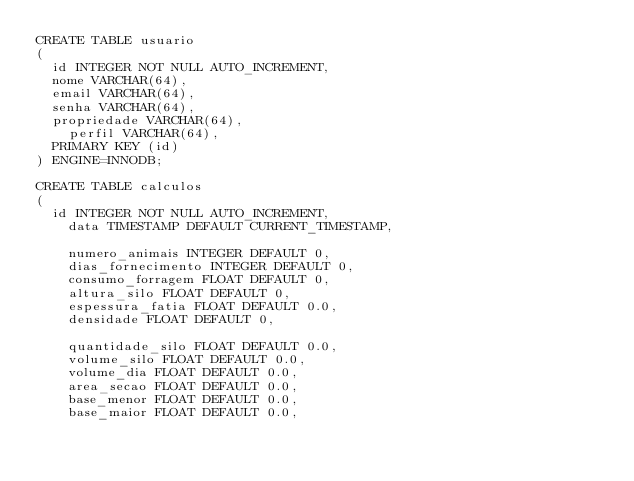Convert code to text. <code><loc_0><loc_0><loc_500><loc_500><_SQL_>CREATE TABLE usuario
(
	id INTEGER NOT NULL AUTO_INCREMENT, 
	nome VARCHAR(64),
	email VARCHAR(64),
	senha VARCHAR(64),
	propriedade VARCHAR(64),
    perfil VARCHAR(64),
	PRIMARY KEY (id)
) ENGINE=INNODB;

CREATE TABLE calculos
(
	id INTEGER NOT NULL AUTO_INCREMENT, 
    data TIMESTAMP DEFAULT CURRENT_TIMESTAMP,

    numero_animais INTEGER DEFAULT 0,
    dias_fornecimento INTEGER DEFAULT 0,
    consumo_forragem FLOAT DEFAULT 0,
    altura_silo FLOAT DEFAULT 0,
    espessura_fatia FLOAT DEFAULT 0.0,
    densidade FLOAT DEFAULT 0,

    quantidade_silo FLOAT DEFAULT 0.0,
    volume_silo FLOAT DEFAULT 0.0,
    volume_dia FLOAT DEFAULT 0.0,
    area_secao FLOAT DEFAULT 0.0,
    base_menor FLOAT DEFAULT 0.0,
    base_maior FLOAT DEFAULT 0.0,</code> 